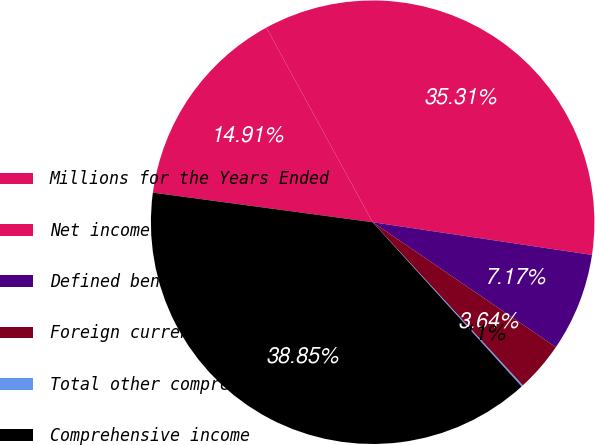Convert chart to OTSL. <chart><loc_0><loc_0><loc_500><loc_500><pie_chart><fcel>Millions for the Years Ended<fcel>Net income<fcel>Defined benefit plans<fcel>Foreign currency translation<fcel>Total other comprehensive<fcel>Comprehensive income<nl><fcel>14.91%<fcel>35.31%<fcel>7.17%<fcel>3.64%<fcel>0.11%<fcel>38.85%<nl></chart> 